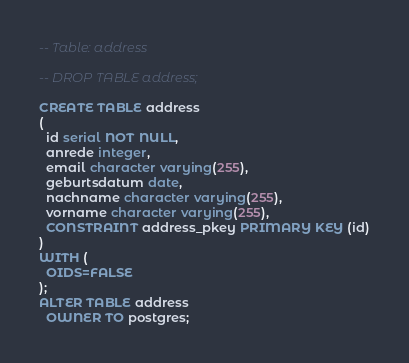Convert code to text. <code><loc_0><loc_0><loc_500><loc_500><_SQL_>-- Table: address

-- DROP TABLE address;

CREATE TABLE address
(
  id serial NOT NULL,
  anrede integer,
  email character varying(255),
  geburtsdatum date,
  nachname character varying(255),
  vorname character varying(255),
  CONSTRAINT address_pkey PRIMARY KEY (id)
)
WITH (
  OIDS=FALSE
);
ALTER TABLE address
  OWNER TO postgres;
</code> 